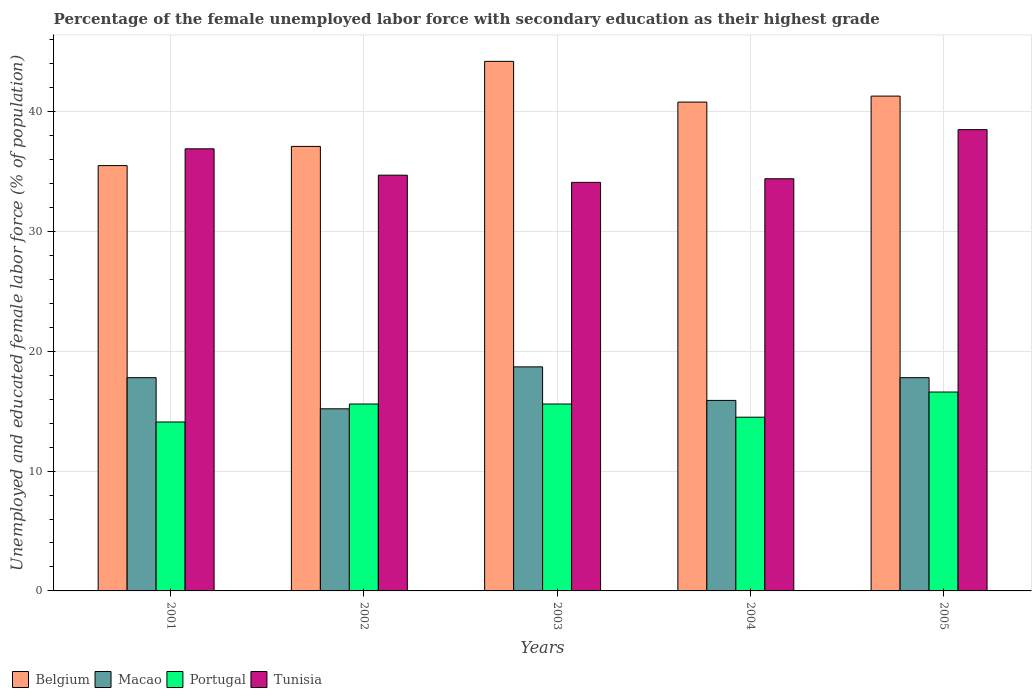How many different coloured bars are there?
Make the answer very short. 4. How many groups of bars are there?
Provide a succinct answer. 5. How many bars are there on the 4th tick from the right?
Your response must be concise. 4. What is the percentage of the unemployed female labor force with secondary education in Macao in 2003?
Make the answer very short. 18.7. Across all years, what is the maximum percentage of the unemployed female labor force with secondary education in Portugal?
Ensure brevity in your answer.  16.6. Across all years, what is the minimum percentage of the unemployed female labor force with secondary education in Macao?
Provide a short and direct response. 15.2. In which year was the percentage of the unemployed female labor force with secondary education in Tunisia maximum?
Offer a very short reply. 2005. In which year was the percentage of the unemployed female labor force with secondary education in Tunisia minimum?
Provide a succinct answer. 2003. What is the total percentage of the unemployed female labor force with secondary education in Tunisia in the graph?
Offer a very short reply. 178.6. What is the difference between the percentage of the unemployed female labor force with secondary education in Belgium in 2001 and that in 2003?
Your answer should be very brief. -8.7. What is the difference between the percentage of the unemployed female labor force with secondary education in Macao in 2005 and the percentage of the unemployed female labor force with secondary education in Belgium in 2002?
Your response must be concise. -19.3. What is the average percentage of the unemployed female labor force with secondary education in Tunisia per year?
Provide a short and direct response. 35.72. In the year 2003, what is the difference between the percentage of the unemployed female labor force with secondary education in Tunisia and percentage of the unemployed female labor force with secondary education in Portugal?
Your answer should be compact. 18.5. What is the ratio of the percentage of the unemployed female labor force with secondary education in Tunisia in 2001 to that in 2005?
Offer a terse response. 0.96. Is the difference between the percentage of the unemployed female labor force with secondary education in Tunisia in 2003 and 2005 greater than the difference between the percentage of the unemployed female labor force with secondary education in Portugal in 2003 and 2005?
Offer a very short reply. No. What is the difference between the highest and the second highest percentage of the unemployed female labor force with secondary education in Portugal?
Keep it short and to the point. 1. What is the difference between the highest and the lowest percentage of the unemployed female labor force with secondary education in Tunisia?
Provide a succinct answer. 4.4. Is the sum of the percentage of the unemployed female labor force with secondary education in Macao in 2001 and 2003 greater than the maximum percentage of the unemployed female labor force with secondary education in Portugal across all years?
Provide a short and direct response. Yes. What does the 4th bar from the left in 2004 represents?
Provide a short and direct response. Tunisia. What does the 1st bar from the right in 2003 represents?
Your answer should be very brief. Tunisia. How many bars are there?
Offer a very short reply. 20. Are all the bars in the graph horizontal?
Provide a succinct answer. No. What is the difference between two consecutive major ticks on the Y-axis?
Make the answer very short. 10. Does the graph contain any zero values?
Offer a terse response. No. How are the legend labels stacked?
Provide a short and direct response. Horizontal. What is the title of the graph?
Keep it short and to the point. Percentage of the female unemployed labor force with secondary education as their highest grade. What is the label or title of the X-axis?
Provide a short and direct response. Years. What is the label or title of the Y-axis?
Your answer should be compact. Unemployed and educated female labor force (% of population). What is the Unemployed and educated female labor force (% of population) of Belgium in 2001?
Keep it short and to the point. 35.5. What is the Unemployed and educated female labor force (% of population) in Macao in 2001?
Offer a very short reply. 17.8. What is the Unemployed and educated female labor force (% of population) in Portugal in 2001?
Provide a short and direct response. 14.1. What is the Unemployed and educated female labor force (% of population) of Tunisia in 2001?
Give a very brief answer. 36.9. What is the Unemployed and educated female labor force (% of population) of Belgium in 2002?
Provide a short and direct response. 37.1. What is the Unemployed and educated female labor force (% of population) in Macao in 2002?
Provide a short and direct response. 15.2. What is the Unemployed and educated female labor force (% of population) of Portugal in 2002?
Keep it short and to the point. 15.6. What is the Unemployed and educated female labor force (% of population) in Tunisia in 2002?
Offer a very short reply. 34.7. What is the Unemployed and educated female labor force (% of population) of Belgium in 2003?
Your response must be concise. 44.2. What is the Unemployed and educated female labor force (% of population) of Macao in 2003?
Keep it short and to the point. 18.7. What is the Unemployed and educated female labor force (% of population) of Portugal in 2003?
Ensure brevity in your answer.  15.6. What is the Unemployed and educated female labor force (% of population) in Tunisia in 2003?
Ensure brevity in your answer.  34.1. What is the Unemployed and educated female labor force (% of population) of Belgium in 2004?
Keep it short and to the point. 40.8. What is the Unemployed and educated female labor force (% of population) of Macao in 2004?
Provide a succinct answer. 15.9. What is the Unemployed and educated female labor force (% of population) in Tunisia in 2004?
Provide a succinct answer. 34.4. What is the Unemployed and educated female labor force (% of population) of Belgium in 2005?
Give a very brief answer. 41.3. What is the Unemployed and educated female labor force (% of population) of Macao in 2005?
Make the answer very short. 17.8. What is the Unemployed and educated female labor force (% of population) of Portugal in 2005?
Ensure brevity in your answer.  16.6. What is the Unemployed and educated female labor force (% of population) in Tunisia in 2005?
Provide a short and direct response. 38.5. Across all years, what is the maximum Unemployed and educated female labor force (% of population) in Belgium?
Provide a succinct answer. 44.2. Across all years, what is the maximum Unemployed and educated female labor force (% of population) in Macao?
Your answer should be very brief. 18.7. Across all years, what is the maximum Unemployed and educated female labor force (% of population) in Portugal?
Your answer should be compact. 16.6. Across all years, what is the maximum Unemployed and educated female labor force (% of population) of Tunisia?
Offer a very short reply. 38.5. Across all years, what is the minimum Unemployed and educated female labor force (% of population) of Belgium?
Offer a terse response. 35.5. Across all years, what is the minimum Unemployed and educated female labor force (% of population) in Macao?
Provide a succinct answer. 15.2. Across all years, what is the minimum Unemployed and educated female labor force (% of population) of Portugal?
Offer a terse response. 14.1. Across all years, what is the minimum Unemployed and educated female labor force (% of population) of Tunisia?
Provide a succinct answer. 34.1. What is the total Unemployed and educated female labor force (% of population) of Belgium in the graph?
Make the answer very short. 198.9. What is the total Unemployed and educated female labor force (% of population) in Macao in the graph?
Give a very brief answer. 85.4. What is the total Unemployed and educated female labor force (% of population) in Portugal in the graph?
Your response must be concise. 76.4. What is the total Unemployed and educated female labor force (% of population) in Tunisia in the graph?
Give a very brief answer. 178.6. What is the difference between the Unemployed and educated female labor force (% of population) in Portugal in 2001 and that in 2002?
Keep it short and to the point. -1.5. What is the difference between the Unemployed and educated female labor force (% of population) in Tunisia in 2001 and that in 2003?
Provide a short and direct response. 2.8. What is the difference between the Unemployed and educated female labor force (% of population) of Tunisia in 2001 and that in 2004?
Ensure brevity in your answer.  2.5. What is the difference between the Unemployed and educated female labor force (% of population) in Belgium in 2001 and that in 2005?
Your response must be concise. -5.8. What is the difference between the Unemployed and educated female labor force (% of population) in Macao in 2001 and that in 2005?
Give a very brief answer. 0. What is the difference between the Unemployed and educated female labor force (% of population) of Portugal in 2001 and that in 2005?
Your answer should be compact. -2.5. What is the difference between the Unemployed and educated female labor force (% of population) in Belgium in 2002 and that in 2003?
Provide a short and direct response. -7.1. What is the difference between the Unemployed and educated female labor force (% of population) of Macao in 2002 and that in 2003?
Provide a succinct answer. -3.5. What is the difference between the Unemployed and educated female labor force (% of population) in Belgium in 2002 and that in 2004?
Your response must be concise. -3.7. What is the difference between the Unemployed and educated female labor force (% of population) of Macao in 2002 and that in 2005?
Keep it short and to the point. -2.6. What is the difference between the Unemployed and educated female labor force (% of population) of Belgium in 2003 and that in 2004?
Your answer should be very brief. 3.4. What is the difference between the Unemployed and educated female labor force (% of population) in Portugal in 2003 and that in 2004?
Your response must be concise. 1.1. What is the difference between the Unemployed and educated female labor force (% of population) in Tunisia in 2003 and that in 2004?
Your answer should be compact. -0.3. What is the difference between the Unemployed and educated female labor force (% of population) in Macao in 2004 and that in 2005?
Provide a short and direct response. -1.9. What is the difference between the Unemployed and educated female labor force (% of population) in Portugal in 2004 and that in 2005?
Keep it short and to the point. -2.1. What is the difference between the Unemployed and educated female labor force (% of population) of Tunisia in 2004 and that in 2005?
Your answer should be compact. -4.1. What is the difference between the Unemployed and educated female labor force (% of population) in Belgium in 2001 and the Unemployed and educated female labor force (% of population) in Macao in 2002?
Provide a succinct answer. 20.3. What is the difference between the Unemployed and educated female labor force (% of population) of Macao in 2001 and the Unemployed and educated female labor force (% of population) of Tunisia in 2002?
Keep it short and to the point. -16.9. What is the difference between the Unemployed and educated female labor force (% of population) in Portugal in 2001 and the Unemployed and educated female labor force (% of population) in Tunisia in 2002?
Offer a terse response. -20.6. What is the difference between the Unemployed and educated female labor force (% of population) of Belgium in 2001 and the Unemployed and educated female labor force (% of population) of Tunisia in 2003?
Make the answer very short. 1.4. What is the difference between the Unemployed and educated female labor force (% of population) of Macao in 2001 and the Unemployed and educated female labor force (% of population) of Tunisia in 2003?
Give a very brief answer. -16.3. What is the difference between the Unemployed and educated female labor force (% of population) in Portugal in 2001 and the Unemployed and educated female labor force (% of population) in Tunisia in 2003?
Ensure brevity in your answer.  -20. What is the difference between the Unemployed and educated female labor force (% of population) in Belgium in 2001 and the Unemployed and educated female labor force (% of population) in Macao in 2004?
Your answer should be compact. 19.6. What is the difference between the Unemployed and educated female labor force (% of population) in Belgium in 2001 and the Unemployed and educated female labor force (% of population) in Tunisia in 2004?
Keep it short and to the point. 1.1. What is the difference between the Unemployed and educated female labor force (% of population) of Macao in 2001 and the Unemployed and educated female labor force (% of population) of Portugal in 2004?
Your answer should be compact. 3.3. What is the difference between the Unemployed and educated female labor force (% of population) in Macao in 2001 and the Unemployed and educated female labor force (% of population) in Tunisia in 2004?
Make the answer very short. -16.6. What is the difference between the Unemployed and educated female labor force (% of population) in Portugal in 2001 and the Unemployed and educated female labor force (% of population) in Tunisia in 2004?
Your answer should be very brief. -20.3. What is the difference between the Unemployed and educated female labor force (% of population) of Macao in 2001 and the Unemployed and educated female labor force (% of population) of Tunisia in 2005?
Provide a short and direct response. -20.7. What is the difference between the Unemployed and educated female labor force (% of population) of Portugal in 2001 and the Unemployed and educated female labor force (% of population) of Tunisia in 2005?
Your answer should be compact. -24.4. What is the difference between the Unemployed and educated female labor force (% of population) of Belgium in 2002 and the Unemployed and educated female labor force (% of population) of Tunisia in 2003?
Offer a terse response. 3. What is the difference between the Unemployed and educated female labor force (% of population) in Macao in 2002 and the Unemployed and educated female labor force (% of population) in Portugal in 2003?
Your response must be concise. -0.4. What is the difference between the Unemployed and educated female labor force (% of population) of Macao in 2002 and the Unemployed and educated female labor force (% of population) of Tunisia in 2003?
Provide a short and direct response. -18.9. What is the difference between the Unemployed and educated female labor force (% of population) in Portugal in 2002 and the Unemployed and educated female labor force (% of population) in Tunisia in 2003?
Provide a short and direct response. -18.5. What is the difference between the Unemployed and educated female labor force (% of population) of Belgium in 2002 and the Unemployed and educated female labor force (% of population) of Macao in 2004?
Your answer should be very brief. 21.2. What is the difference between the Unemployed and educated female labor force (% of population) in Belgium in 2002 and the Unemployed and educated female labor force (% of population) in Portugal in 2004?
Your answer should be compact. 22.6. What is the difference between the Unemployed and educated female labor force (% of population) of Macao in 2002 and the Unemployed and educated female labor force (% of population) of Tunisia in 2004?
Your answer should be compact. -19.2. What is the difference between the Unemployed and educated female labor force (% of population) in Portugal in 2002 and the Unemployed and educated female labor force (% of population) in Tunisia in 2004?
Keep it short and to the point. -18.8. What is the difference between the Unemployed and educated female labor force (% of population) of Belgium in 2002 and the Unemployed and educated female labor force (% of population) of Macao in 2005?
Offer a very short reply. 19.3. What is the difference between the Unemployed and educated female labor force (% of population) in Belgium in 2002 and the Unemployed and educated female labor force (% of population) in Portugal in 2005?
Your answer should be compact. 20.5. What is the difference between the Unemployed and educated female labor force (% of population) in Macao in 2002 and the Unemployed and educated female labor force (% of population) in Tunisia in 2005?
Your answer should be compact. -23.3. What is the difference between the Unemployed and educated female labor force (% of population) in Portugal in 2002 and the Unemployed and educated female labor force (% of population) in Tunisia in 2005?
Offer a very short reply. -22.9. What is the difference between the Unemployed and educated female labor force (% of population) of Belgium in 2003 and the Unemployed and educated female labor force (% of population) of Macao in 2004?
Offer a terse response. 28.3. What is the difference between the Unemployed and educated female labor force (% of population) in Belgium in 2003 and the Unemployed and educated female labor force (% of population) in Portugal in 2004?
Your answer should be very brief. 29.7. What is the difference between the Unemployed and educated female labor force (% of population) in Belgium in 2003 and the Unemployed and educated female labor force (% of population) in Tunisia in 2004?
Offer a very short reply. 9.8. What is the difference between the Unemployed and educated female labor force (% of population) in Macao in 2003 and the Unemployed and educated female labor force (% of population) in Portugal in 2004?
Your answer should be compact. 4.2. What is the difference between the Unemployed and educated female labor force (% of population) in Macao in 2003 and the Unemployed and educated female labor force (% of population) in Tunisia in 2004?
Your answer should be very brief. -15.7. What is the difference between the Unemployed and educated female labor force (% of population) of Portugal in 2003 and the Unemployed and educated female labor force (% of population) of Tunisia in 2004?
Your response must be concise. -18.8. What is the difference between the Unemployed and educated female labor force (% of population) in Belgium in 2003 and the Unemployed and educated female labor force (% of population) in Macao in 2005?
Your answer should be very brief. 26.4. What is the difference between the Unemployed and educated female labor force (% of population) of Belgium in 2003 and the Unemployed and educated female labor force (% of population) of Portugal in 2005?
Give a very brief answer. 27.6. What is the difference between the Unemployed and educated female labor force (% of population) in Macao in 2003 and the Unemployed and educated female labor force (% of population) in Tunisia in 2005?
Your answer should be very brief. -19.8. What is the difference between the Unemployed and educated female labor force (% of population) of Portugal in 2003 and the Unemployed and educated female labor force (% of population) of Tunisia in 2005?
Your answer should be compact. -22.9. What is the difference between the Unemployed and educated female labor force (% of population) in Belgium in 2004 and the Unemployed and educated female labor force (% of population) in Portugal in 2005?
Offer a terse response. 24.2. What is the difference between the Unemployed and educated female labor force (% of population) of Belgium in 2004 and the Unemployed and educated female labor force (% of population) of Tunisia in 2005?
Your response must be concise. 2.3. What is the difference between the Unemployed and educated female labor force (% of population) of Macao in 2004 and the Unemployed and educated female labor force (% of population) of Portugal in 2005?
Make the answer very short. -0.7. What is the difference between the Unemployed and educated female labor force (% of population) of Macao in 2004 and the Unemployed and educated female labor force (% of population) of Tunisia in 2005?
Offer a very short reply. -22.6. What is the average Unemployed and educated female labor force (% of population) in Belgium per year?
Ensure brevity in your answer.  39.78. What is the average Unemployed and educated female labor force (% of population) in Macao per year?
Your response must be concise. 17.08. What is the average Unemployed and educated female labor force (% of population) in Portugal per year?
Provide a succinct answer. 15.28. What is the average Unemployed and educated female labor force (% of population) of Tunisia per year?
Make the answer very short. 35.72. In the year 2001, what is the difference between the Unemployed and educated female labor force (% of population) in Belgium and Unemployed and educated female labor force (% of population) in Portugal?
Offer a very short reply. 21.4. In the year 2001, what is the difference between the Unemployed and educated female labor force (% of population) in Belgium and Unemployed and educated female labor force (% of population) in Tunisia?
Your response must be concise. -1.4. In the year 2001, what is the difference between the Unemployed and educated female labor force (% of population) in Macao and Unemployed and educated female labor force (% of population) in Portugal?
Your answer should be compact. 3.7. In the year 2001, what is the difference between the Unemployed and educated female labor force (% of population) in Macao and Unemployed and educated female labor force (% of population) in Tunisia?
Your answer should be compact. -19.1. In the year 2001, what is the difference between the Unemployed and educated female labor force (% of population) of Portugal and Unemployed and educated female labor force (% of population) of Tunisia?
Ensure brevity in your answer.  -22.8. In the year 2002, what is the difference between the Unemployed and educated female labor force (% of population) in Belgium and Unemployed and educated female labor force (% of population) in Macao?
Ensure brevity in your answer.  21.9. In the year 2002, what is the difference between the Unemployed and educated female labor force (% of population) in Macao and Unemployed and educated female labor force (% of population) in Tunisia?
Keep it short and to the point. -19.5. In the year 2002, what is the difference between the Unemployed and educated female labor force (% of population) in Portugal and Unemployed and educated female labor force (% of population) in Tunisia?
Your response must be concise. -19.1. In the year 2003, what is the difference between the Unemployed and educated female labor force (% of population) in Belgium and Unemployed and educated female labor force (% of population) in Macao?
Ensure brevity in your answer.  25.5. In the year 2003, what is the difference between the Unemployed and educated female labor force (% of population) in Belgium and Unemployed and educated female labor force (% of population) in Portugal?
Keep it short and to the point. 28.6. In the year 2003, what is the difference between the Unemployed and educated female labor force (% of population) of Belgium and Unemployed and educated female labor force (% of population) of Tunisia?
Provide a succinct answer. 10.1. In the year 2003, what is the difference between the Unemployed and educated female labor force (% of population) of Macao and Unemployed and educated female labor force (% of population) of Portugal?
Provide a short and direct response. 3.1. In the year 2003, what is the difference between the Unemployed and educated female labor force (% of population) in Macao and Unemployed and educated female labor force (% of population) in Tunisia?
Provide a short and direct response. -15.4. In the year 2003, what is the difference between the Unemployed and educated female labor force (% of population) of Portugal and Unemployed and educated female labor force (% of population) of Tunisia?
Ensure brevity in your answer.  -18.5. In the year 2004, what is the difference between the Unemployed and educated female labor force (% of population) of Belgium and Unemployed and educated female labor force (% of population) of Macao?
Make the answer very short. 24.9. In the year 2004, what is the difference between the Unemployed and educated female labor force (% of population) of Belgium and Unemployed and educated female labor force (% of population) of Portugal?
Your answer should be very brief. 26.3. In the year 2004, what is the difference between the Unemployed and educated female labor force (% of population) in Belgium and Unemployed and educated female labor force (% of population) in Tunisia?
Make the answer very short. 6.4. In the year 2004, what is the difference between the Unemployed and educated female labor force (% of population) of Macao and Unemployed and educated female labor force (% of population) of Portugal?
Your answer should be compact. 1.4. In the year 2004, what is the difference between the Unemployed and educated female labor force (% of population) in Macao and Unemployed and educated female labor force (% of population) in Tunisia?
Keep it short and to the point. -18.5. In the year 2004, what is the difference between the Unemployed and educated female labor force (% of population) of Portugal and Unemployed and educated female labor force (% of population) of Tunisia?
Offer a very short reply. -19.9. In the year 2005, what is the difference between the Unemployed and educated female labor force (% of population) in Belgium and Unemployed and educated female labor force (% of population) in Portugal?
Provide a succinct answer. 24.7. In the year 2005, what is the difference between the Unemployed and educated female labor force (% of population) in Belgium and Unemployed and educated female labor force (% of population) in Tunisia?
Offer a very short reply. 2.8. In the year 2005, what is the difference between the Unemployed and educated female labor force (% of population) of Macao and Unemployed and educated female labor force (% of population) of Portugal?
Provide a succinct answer. 1.2. In the year 2005, what is the difference between the Unemployed and educated female labor force (% of population) of Macao and Unemployed and educated female labor force (% of population) of Tunisia?
Your answer should be compact. -20.7. In the year 2005, what is the difference between the Unemployed and educated female labor force (% of population) of Portugal and Unemployed and educated female labor force (% of population) of Tunisia?
Keep it short and to the point. -21.9. What is the ratio of the Unemployed and educated female labor force (% of population) of Belgium in 2001 to that in 2002?
Keep it short and to the point. 0.96. What is the ratio of the Unemployed and educated female labor force (% of population) in Macao in 2001 to that in 2002?
Ensure brevity in your answer.  1.17. What is the ratio of the Unemployed and educated female labor force (% of population) in Portugal in 2001 to that in 2002?
Your answer should be very brief. 0.9. What is the ratio of the Unemployed and educated female labor force (% of population) in Tunisia in 2001 to that in 2002?
Your answer should be compact. 1.06. What is the ratio of the Unemployed and educated female labor force (% of population) of Belgium in 2001 to that in 2003?
Your answer should be very brief. 0.8. What is the ratio of the Unemployed and educated female labor force (% of population) of Macao in 2001 to that in 2003?
Your answer should be very brief. 0.95. What is the ratio of the Unemployed and educated female labor force (% of population) in Portugal in 2001 to that in 2003?
Provide a short and direct response. 0.9. What is the ratio of the Unemployed and educated female labor force (% of population) of Tunisia in 2001 to that in 2003?
Make the answer very short. 1.08. What is the ratio of the Unemployed and educated female labor force (% of population) of Belgium in 2001 to that in 2004?
Offer a very short reply. 0.87. What is the ratio of the Unemployed and educated female labor force (% of population) of Macao in 2001 to that in 2004?
Give a very brief answer. 1.12. What is the ratio of the Unemployed and educated female labor force (% of population) in Portugal in 2001 to that in 2004?
Provide a short and direct response. 0.97. What is the ratio of the Unemployed and educated female labor force (% of population) in Tunisia in 2001 to that in 2004?
Your answer should be very brief. 1.07. What is the ratio of the Unemployed and educated female labor force (% of population) of Belgium in 2001 to that in 2005?
Keep it short and to the point. 0.86. What is the ratio of the Unemployed and educated female labor force (% of population) in Macao in 2001 to that in 2005?
Your answer should be compact. 1. What is the ratio of the Unemployed and educated female labor force (% of population) in Portugal in 2001 to that in 2005?
Provide a succinct answer. 0.85. What is the ratio of the Unemployed and educated female labor force (% of population) in Tunisia in 2001 to that in 2005?
Your answer should be compact. 0.96. What is the ratio of the Unemployed and educated female labor force (% of population) in Belgium in 2002 to that in 2003?
Provide a short and direct response. 0.84. What is the ratio of the Unemployed and educated female labor force (% of population) of Macao in 2002 to that in 2003?
Provide a succinct answer. 0.81. What is the ratio of the Unemployed and educated female labor force (% of population) in Tunisia in 2002 to that in 2003?
Provide a short and direct response. 1.02. What is the ratio of the Unemployed and educated female labor force (% of population) in Belgium in 2002 to that in 2004?
Keep it short and to the point. 0.91. What is the ratio of the Unemployed and educated female labor force (% of population) in Macao in 2002 to that in 2004?
Ensure brevity in your answer.  0.96. What is the ratio of the Unemployed and educated female labor force (% of population) in Portugal in 2002 to that in 2004?
Your response must be concise. 1.08. What is the ratio of the Unemployed and educated female labor force (% of population) of Tunisia in 2002 to that in 2004?
Your response must be concise. 1.01. What is the ratio of the Unemployed and educated female labor force (% of population) in Belgium in 2002 to that in 2005?
Keep it short and to the point. 0.9. What is the ratio of the Unemployed and educated female labor force (% of population) in Macao in 2002 to that in 2005?
Provide a succinct answer. 0.85. What is the ratio of the Unemployed and educated female labor force (% of population) in Portugal in 2002 to that in 2005?
Ensure brevity in your answer.  0.94. What is the ratio of the Unemployed and educated female labor force (% of population) in Tunisia in 2002 to that in 2005?
Keep it short and to the point. 0.9. What is the ratio of the Unemployed and educated female labor force (% of population) in Belgium in 2003 to that in 2004?
Keep it short and to the point. 1.08. What is the ratio of the Unemployed and educated female labor force (% of population) of Macao in 2003 to that in 2004?
Keep it short and to the point. 1.18. What is the ratio of the Unemployed and educated female labor force (% of population) of Portugal in 2003 to that in 2004?
Keep it short and to the point. 1.08. What is the ratio of the Unemployed and educated female labor force (% of population) in Belgium in 2003 to that in 2005?
Your answer should be compact. 1.07. What is the ratio of the Unemployed and educated female labor force (% of population) in Macao in 2003 to that in 2005?
Your response must be concise. 1.05. What is the ratio of the Unemployed and educated female labor force (% of population) of Portugal in 2003 to that in 2005?
Your answer should be very brief. 0.94. What is the ratio of the Unemployed and educated female labor force (% of population) of Tunisia in 2003 to that in 2005?
Keep it short and to the point. 0.89. What is the ratio of the Unemployed and educated female labor force (% of population) in Belgium in 2004 to that in 2005?
Provide a short and direct response. 0.99. What is the ratio of the Unemployed and educated female labor force (% of population) of Macao in 2004 to that in 2005?
Offer a very short reply. 0.89. What is the ratio of the Unemployed and educated female labor force (% of population) of Portugal in 2004 to that in 2005?
Make the answer very short. 0.87. What is the ratio of the Unemployed and educated female labor force (% of population) in Tunisia in 2004 to that in 2005?
Ensure brevity in your answer.  0.89. What is the difference between the highest and the second highest Unemployed and educated female labor force (% of population) of Belgium?
Ensure brevity in your answer.  2.9. What is the difference between the highest and the second highest Unemployed and educated female labor force (% of population) of Portugal?
Your response must be concise. 1. What is the difference between the highest and the lowest Unemployed and educated female labor force (% of population) of Belgium?
Your answer should be very brief. 8.7. 